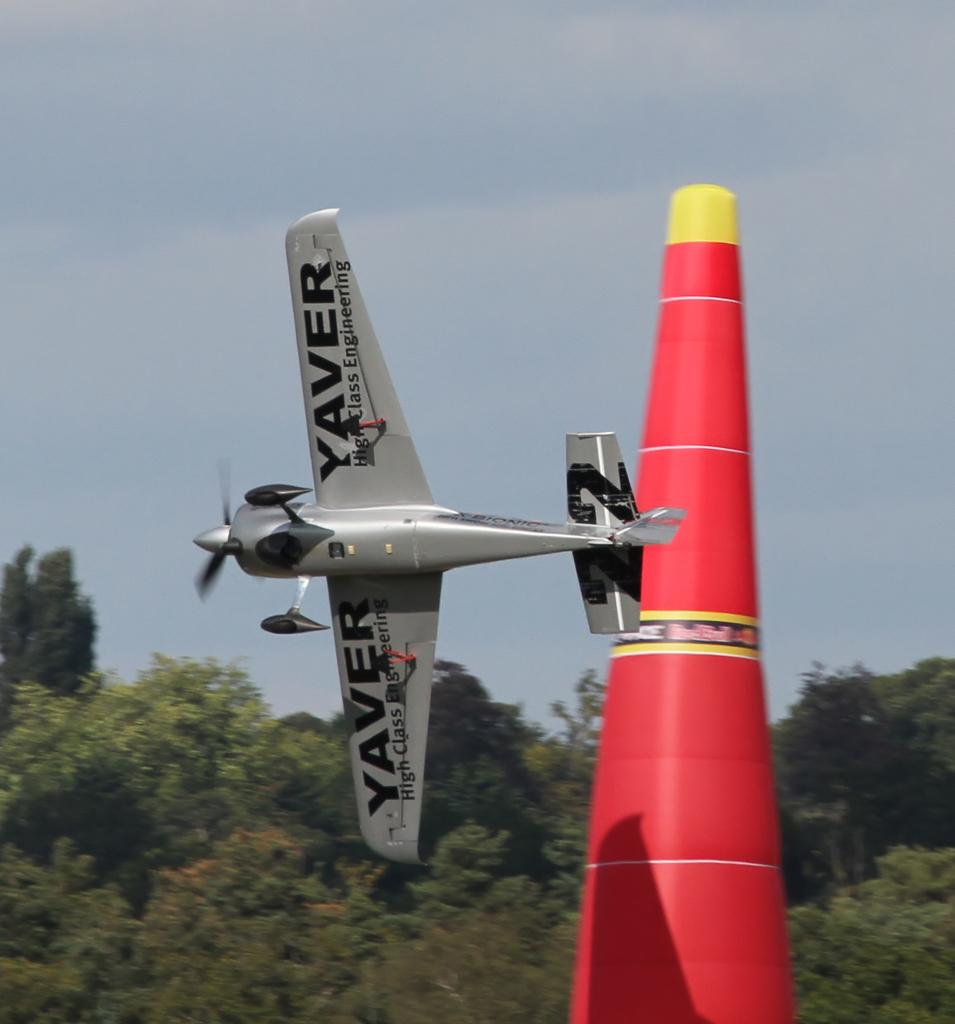<image>
Describe the image concisely. A plane is flying by a giant red cone that says Red Bull. 